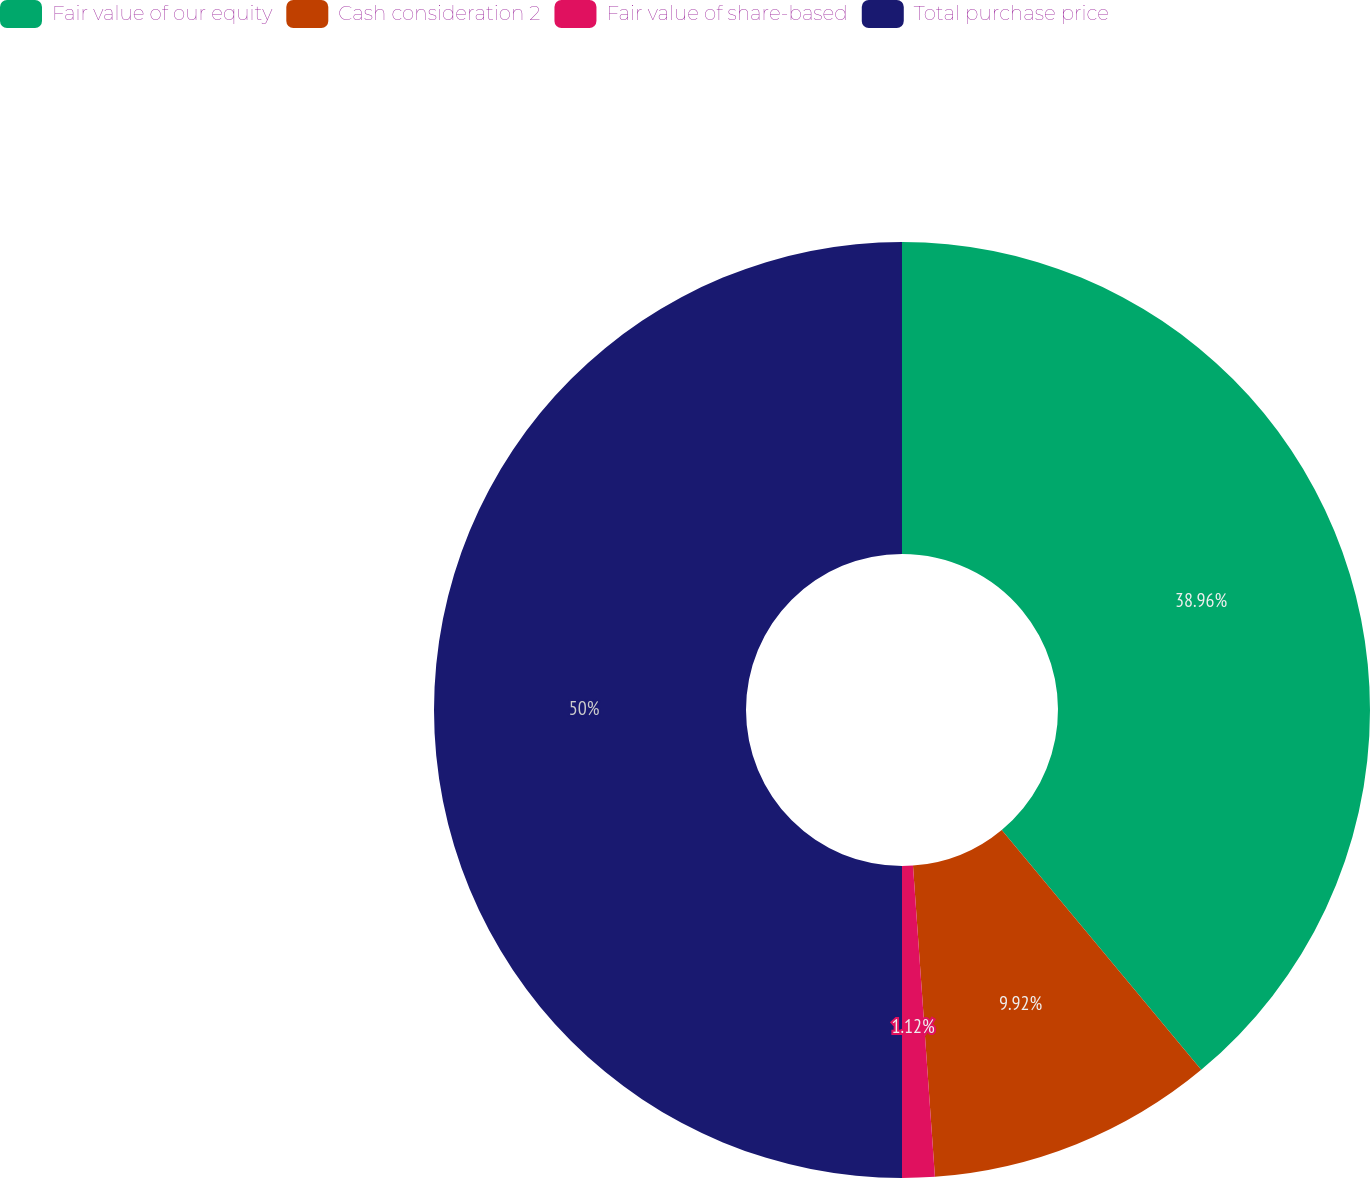Convert chart to OTSL. <chart><loc_0><loc_0><loc_500><loc_500><pie_chart><fcel>Fair value of our equity<fcel>Cash consideration 2<fcel>Fair value of share-based<fcel>Total purchase price<nl><fcel>38.96%<fcel>9.92%<fcel>1.12%<fcel>50.0%<nl></chart> 